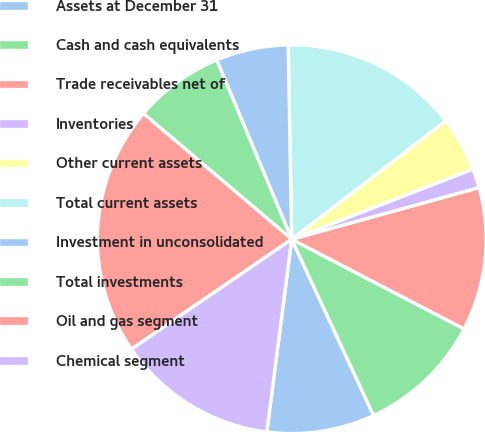<chart> <loc_0><loc_0><loc_500><loc_500><pie_chart><fcel>Assets at December 31<fcel>Cash and cash equivalents<fcel>Trade receivables net of<fcel>Inventories<fcel>Other current assets<fcel>Total current assets<fcel>Investment in unconsolidated<fcel>Total investments<fcel>Oil and gas segment<fcel>Chemical segment<nl><fcel>8.97%<fcel>10.44%<fcel>11.92%<fcel>1.6%<fcel>4.55%<fcel>14.86%<fcel>6.02%<fcel>7.5%<fcel>20.76%<fcel>13.39%<nl></chart> 